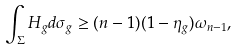<formula> <loc_0><loc_0><loc_500><loc_500>\int _ { \Sigma } H _ { g } d \sigma _ { g } \geq ( n - 1 ) ( 1 - \eta _ { g } ) \omega _ { n - 1 } ,</formula> 